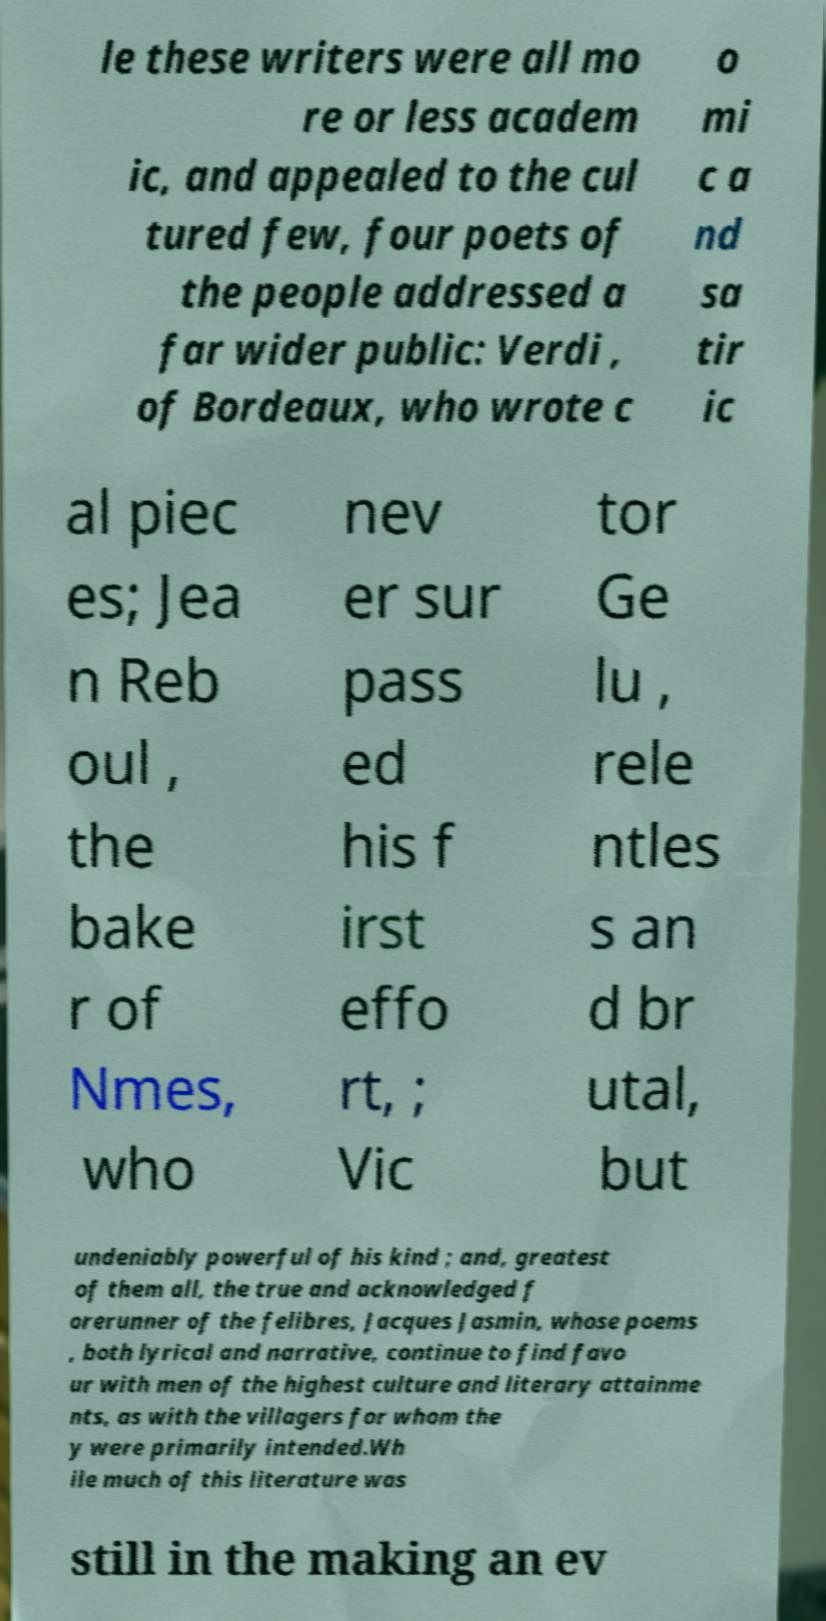Could you extract and type out the text from this image? le these writers were all mo re or less academ ic, and appealed to the cul tured few, four poets of the people addressed a far wider public: Verdi , of Bordeaux, who wrote c o mi c a nd sa tir ic al piec es; Jea n Reb oul , the bake r of Nmes, who nev er sur pass ed his f irst effo rt, ; Vic tor Ge lu , rele ntles s an d br utal, but undeniably powerful of his kind ; and, greatest of them all, the true and acknowledged f orerunner of the felibres, Jacques Jasmin, whose poems , both lyrical and narrative, continue to find favo ur with men of the highest culture and literary attainme nts, as with the villagers for whom the y were primarily intended.Wh ile much of this literature was still in the making an ev 